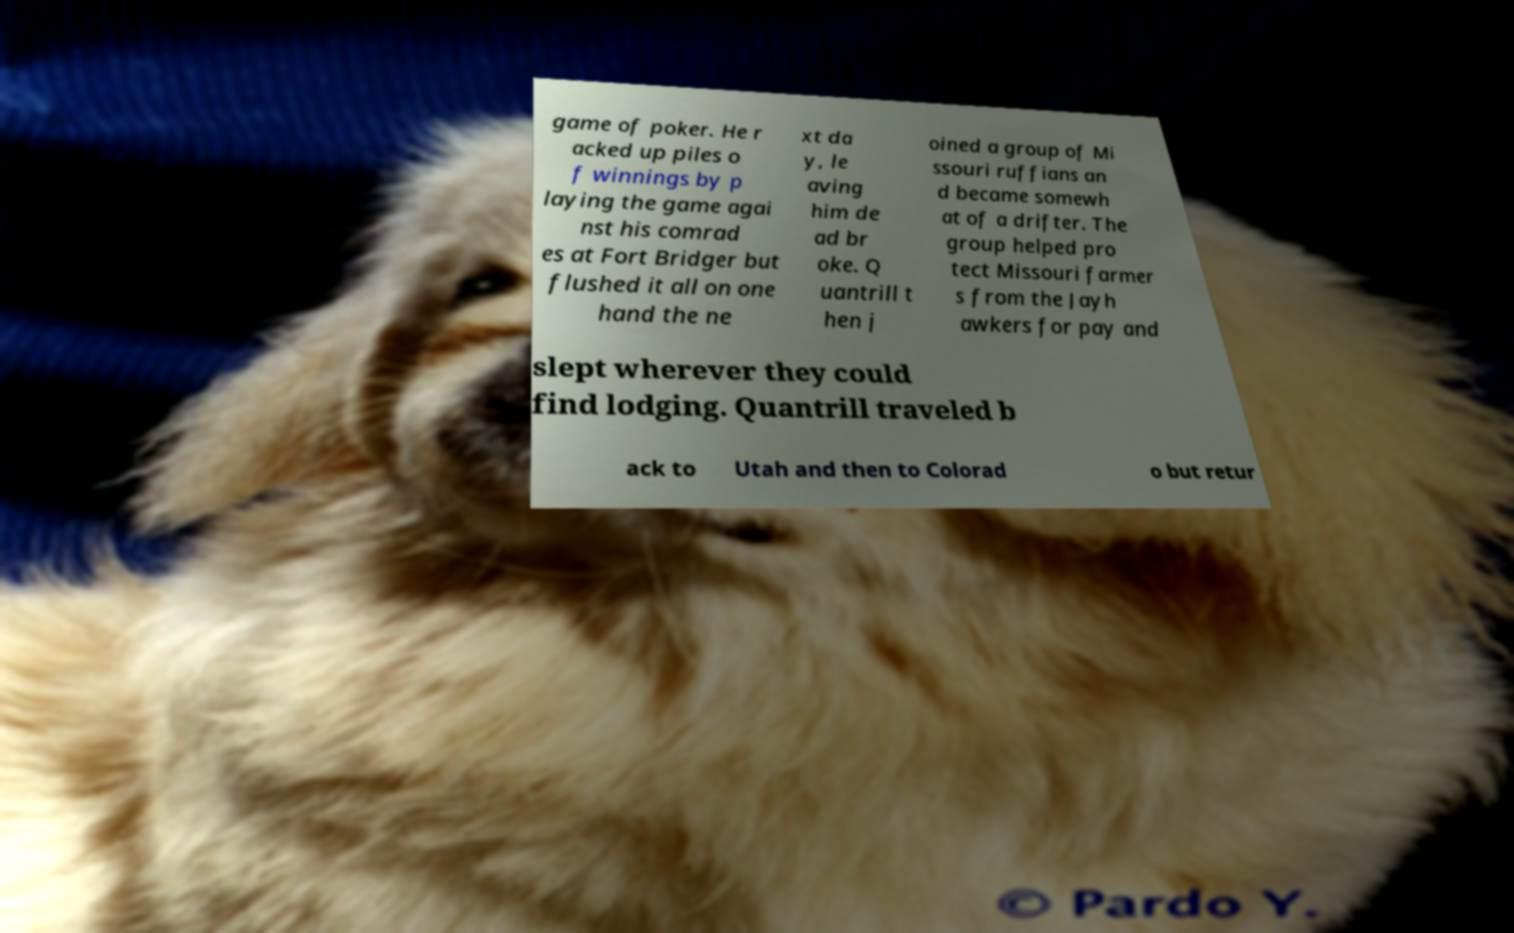What messages or text are displayed in this image? I need them in a readable, typed format. game of poker. He r acked up piles o f winnings by p laying the game agai nst his comrad es at Fort Bridger but flushed it all on one hand the ne xt da y, le aving him de ad br oke. Q uantrill t hen j oined a group of Mi ssouri ruffians an d became somewh at of a drifter. The group helped pro tect Missouri farmer s from the Jayh awkers for pay and slept wherever they could find lodging. Quantrill traveled b ack to Utah and then to Colorad o but retur 